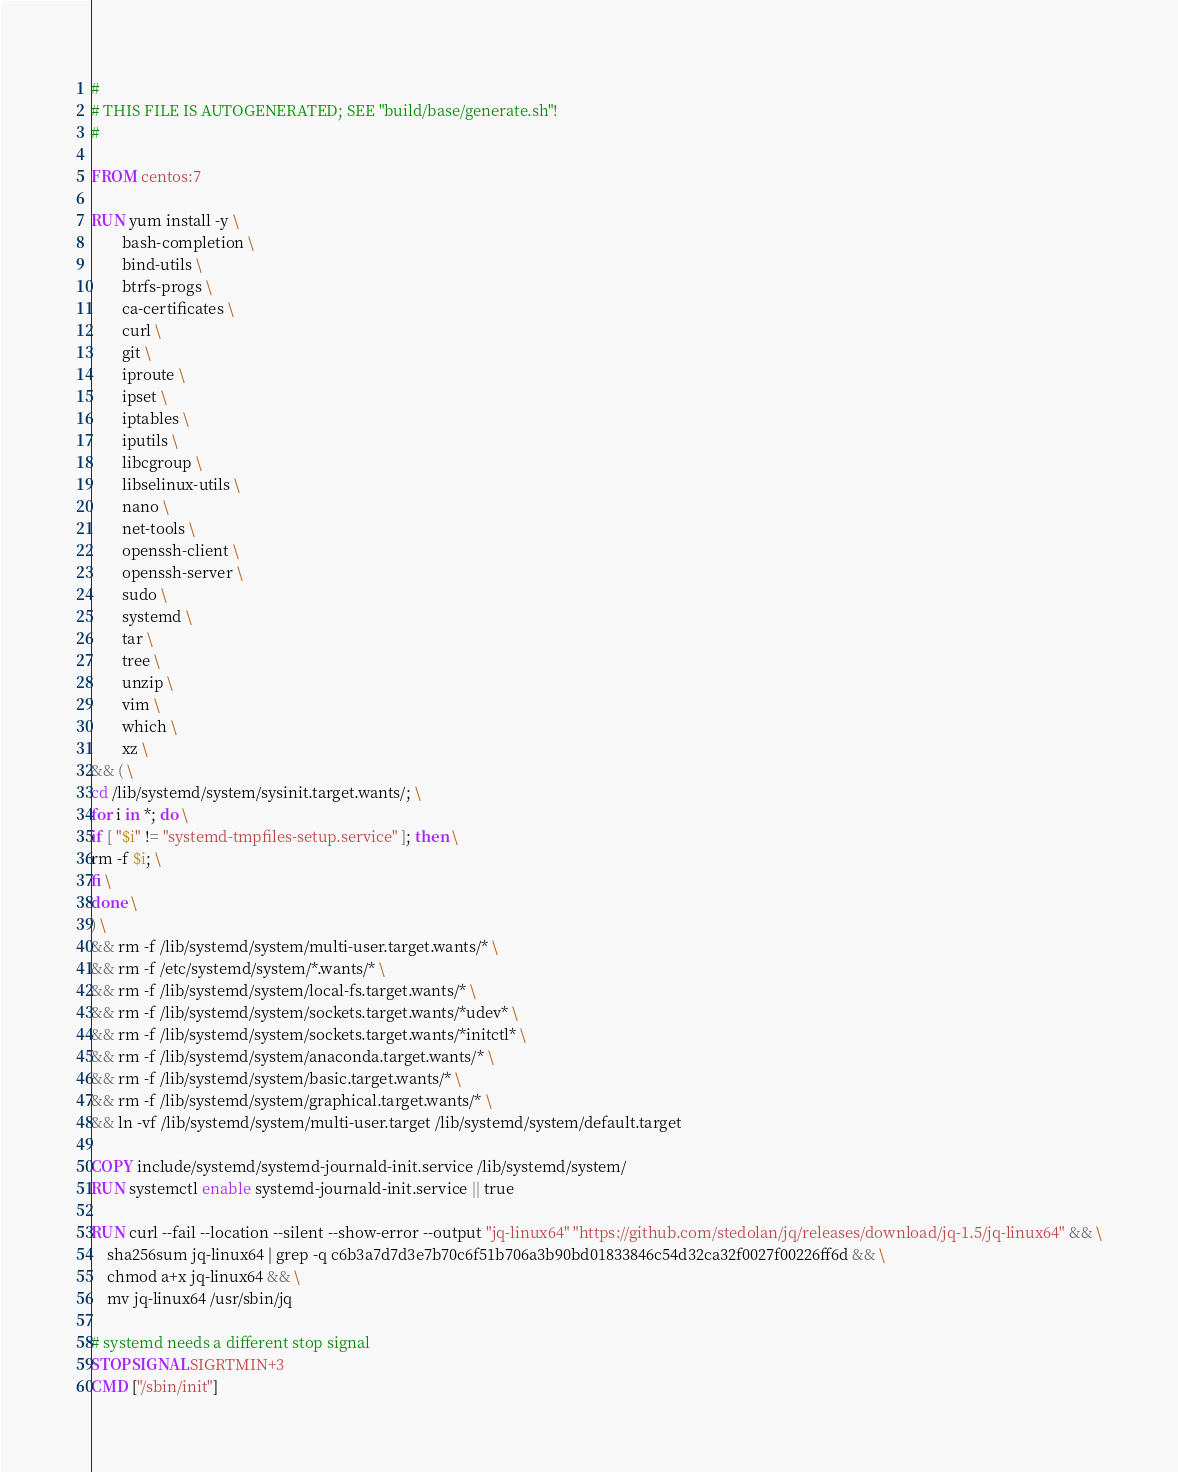<code> <loc_0><loc_0><loc_500><loc_500><_Dockerfile_>#
# THIS FILE IS AUTOGENERATED; SEE "build/base/generate.sh"!
#

FROM centos:7

RUN yum install -y \
		bash-completion \
		bind-utils \
		btrfs-progs \
		ca-certificates \
		curl \
		git \
		iproute \
		ipset \
		iptables \
		iputils \
		libcgroup \
		libselinux-utils \
		nano \
		net-tools \
		openssh-client \
		openssh-server \
		sudo \
		systemd \
		tar \
		tree \
		unzip \
		vim \
		which \
		xz \
&& ( \
cd /lib/systemd/system/sysinit.target.wants/; \
for i in *; do \
if [ "$i" != "systemd-tmpfiles-setup.service" ]; then \
rm -f $i; \
fi \
done \
) \
&& rm -f /lib/systemd/system/multi-user.target.wants/* \
&& rm -f /etc/systemd/system/*.wants/* \
&& rm -f /lib/systemd/system/local-fs.target.wants/* \
&& rm -f /lib/systemd/system/sockets.target.wants/*udev* \
&& rm -f /lib/systemd/system/sockets.target.wants/*initctl* \
&& rm -f /lib/systemd/system/anaconda.target.wants/* \
&& rm -f /lib/systemd/system/basic.target.wants/* \
&& rm -f /lib/systemd/system/graphical.target.wants/* \
&& ln -vf /lib/systemd/system/multi-user.target /lib/systemd/system/default.target

COPY include/systemd/systemd-journald-init.service /lib/systemd/system/
RUN systemctl enable systemd-journald-init.service || true

RUN curl --fail --location --silent --show-error --output "jq-linux64" "https://github.com/stedolan/jq/releases/download/jq-1.5/jq-linux64" && \
    sha256sum jq-linux64 | grep -q c6b3a7d7d3e7b70c6f51b706a3b90bd01833846c54d32ca32f0027f00226ff6d && \
    chmod a+x jq-linux64 && \
    mv jq-linux64 /usr/sbin/jq

# systemd needs a different stop signal
STOPSIGNAL SIGRTMIN+3
CMD ["/sbin/init"]
</code> 